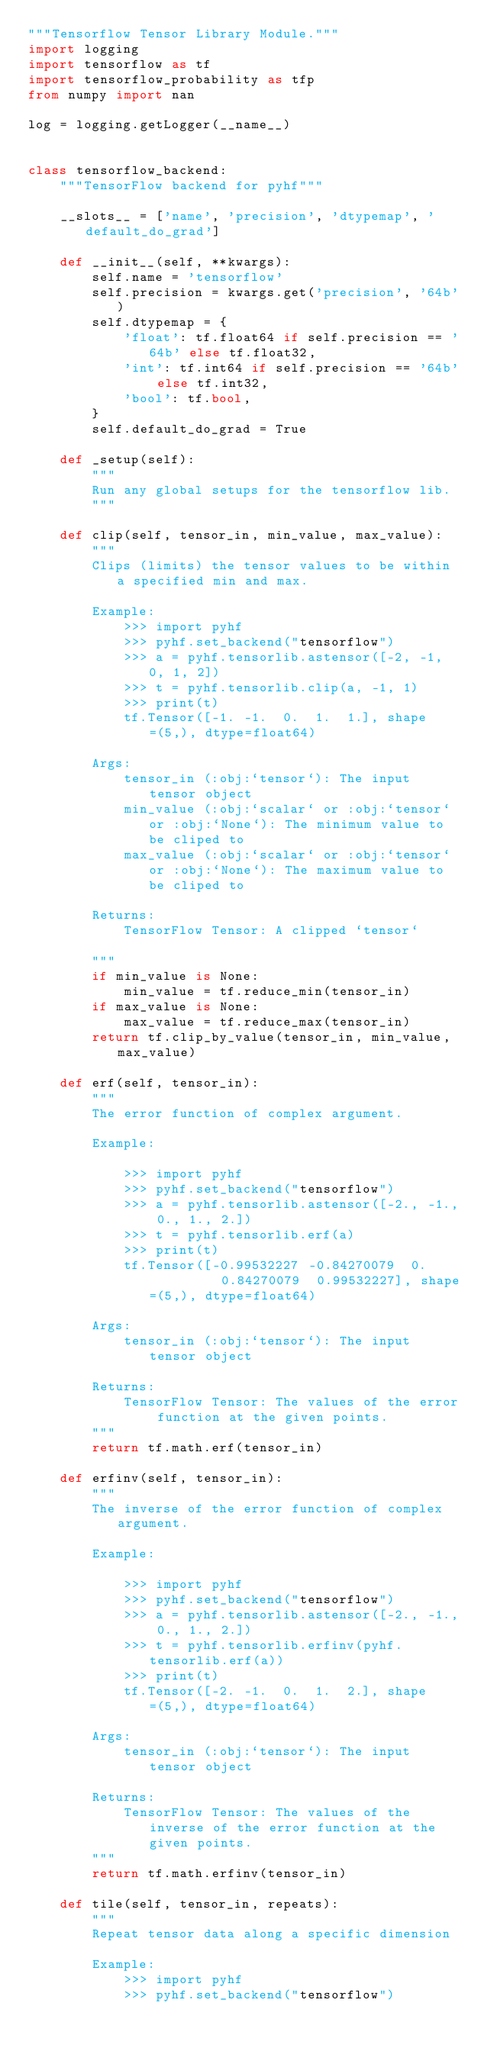Convert code to text. <code><loc_0><loc_0><loc_500><loc_500><_Python_>"""Tensorflow Tensor Library Module."""
import logging
import tensorflow as tf
import tensorflow_probability as tfp
from numpy import nan

log = logging.getLogger(__name__)


class tensorflow_backend:
    """TensorFlow backend for pyhf"""

    __slots__ = ['name', 'precision', 'dtypemap', 'default_do_grad']

    def __init__(self, **kwargs):
        self.name = 'tensorflow'
        self.precision = kwargs.get('precision', '64b')
        self.dtypemap = {
            'float': tf.float64 if self.precision == '64b' else tf.float32,
            'int': tf.int64 if self.precision == '64b' else tf.int32,
            'bool': tf.bool,
        }
        self.default_do_grad = True

    def _setup(self):
        """
        Run any global setups for the tensorflow lib.
        """

    def clip(self, tensor_in, min_value, max_value):
        """
        Clips (limits) the tensor values to be within a specified min and max.

        Example:
            >>> import pyhf
            >>> pyhf.set_backend("tensorflow")
            >>> a = pyhf.tensorlib.astensor([-2, -1, 0, 1, 2])
            >>> t = pyhf.tensorlib.clip(a, -1, 1)
            >>> print(t)
            tf.Tensor([-1. -1.  0.  1.  1.], shape=(5,), dtype=float64)

        Args:
            tensor_in (:obj:`tensor`): The input tensor object
            min_value (:obj:`scalar` or :obj:`tensor` or :obj:`None`): The minimum value to be cliped to
            max_value (:obj:`scalar` or :obj:`tensor` or :obj:`None`): The maximum value to be cliped to

        Returns:
            TensorFlow Tensor: A clipped `tensor`

        """
        if min_value is None:
            min_value = tf.reduce_min(tensor_in)
        if max_value is None:
            max_value = tf.reduce_max(tensor_in)
        return tf.clip_by_value(tensor_in, min_value, max_value)

    def erf(self, tensor_in):
        """
        The error function of complex argument.

        Example:

            >>> import pyhf
            >>> pyhf.set_backend("tensorflow")
            >>> a = pyhf.tensorlib.astensor([-2., -1., 0., 1., 2.])
            >>> t = pyhf.tensorlib.erf(a)
            >>> print(t)
            tf.Tensor([-0.99532227 -0.84270079  0.          0.84270079  0.99532227], shape=(5,), dtype=float64)

        Args:
            tensor_in (:obj:`tensor`): The input tensor object

        Returns:
            TensorFlow Tensor: The values of the error function at the given points.
        """
        return tf.math.erf(tensor_in)

    def erfinv(self, tensor_in):
        """
        The inverse of the error function of complex argument.

        Example:

            >>> import pyhf
            >>> pyhf.set_backend("tensorflow")
            >>> a = pyhf.tensorlib.astensor([-2., -1., 0., 1., 2.])
            >>> t = pyhf.tensorlib.erfinv(pyhf.tensorlib.erf(a))
            >>> print(t)
            tf.Tensor([-2. -1.  0.  1.  2.], shape=(5,), dtype=float64)

        Args:
            tensor_in (:obj:`tensor`): The input tensor object

        Returns:
            TensorFlow Tensor: The values of the inverse of the error function at the given points.
        """
        return tf.math.erfinv(tensor_in)

    def tile(self, tensor_in, repeats):
        """
        Repeat tensor data along a specific dimension

        Example:
            >>> import pyhf
            >>> pyhf.set_backend("tensorflow")</code> 